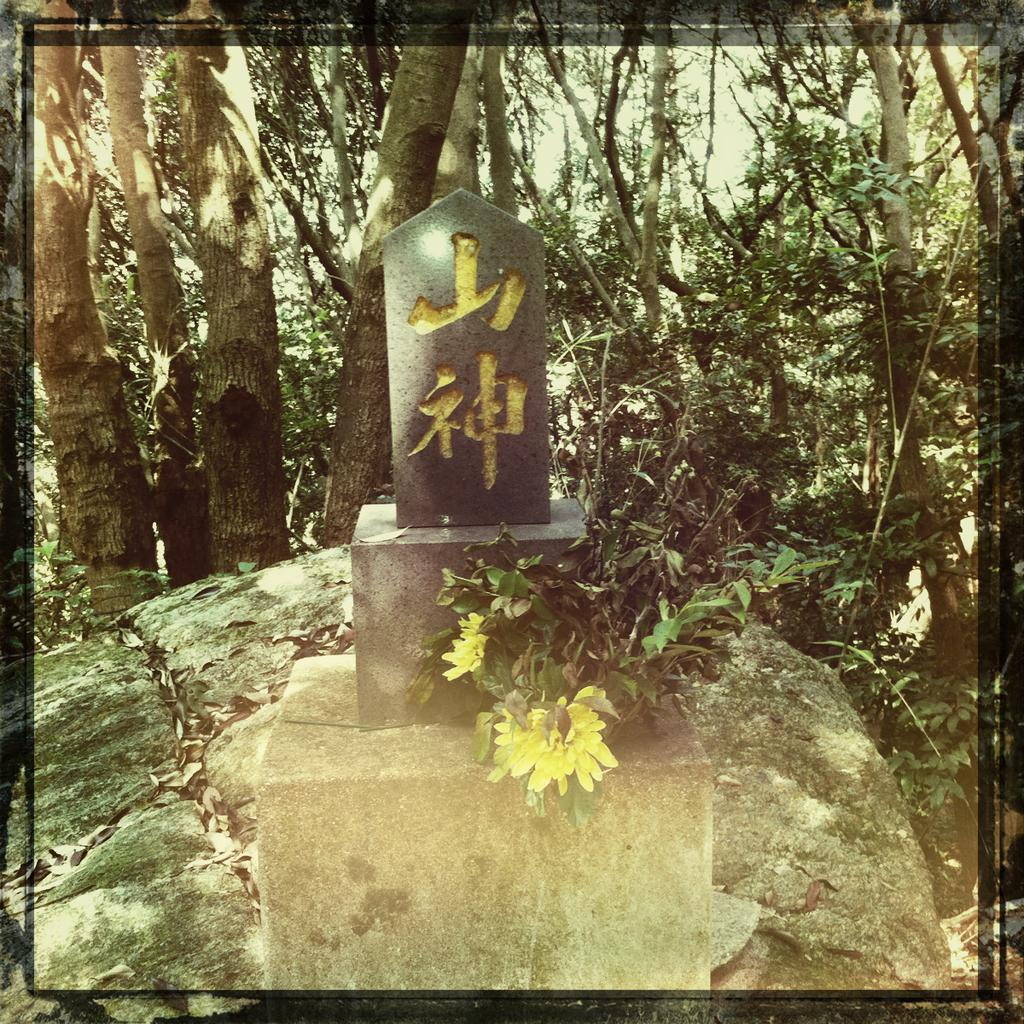What type of vegetation can be seen in the image? There are trees in the image. What is present on the ground in the image? Dried leaves, stones, and rocks are visible in the image. What else can be seen in the image besides vegetation and ground elements? Branches are in the image. What type of structure is present in the image? There is a wall in the image. Can you tell me how many animals are visible in the image? There are no animals present in the image. What type of downtown area can be seen in the image? There is no downtown area present in the image. 